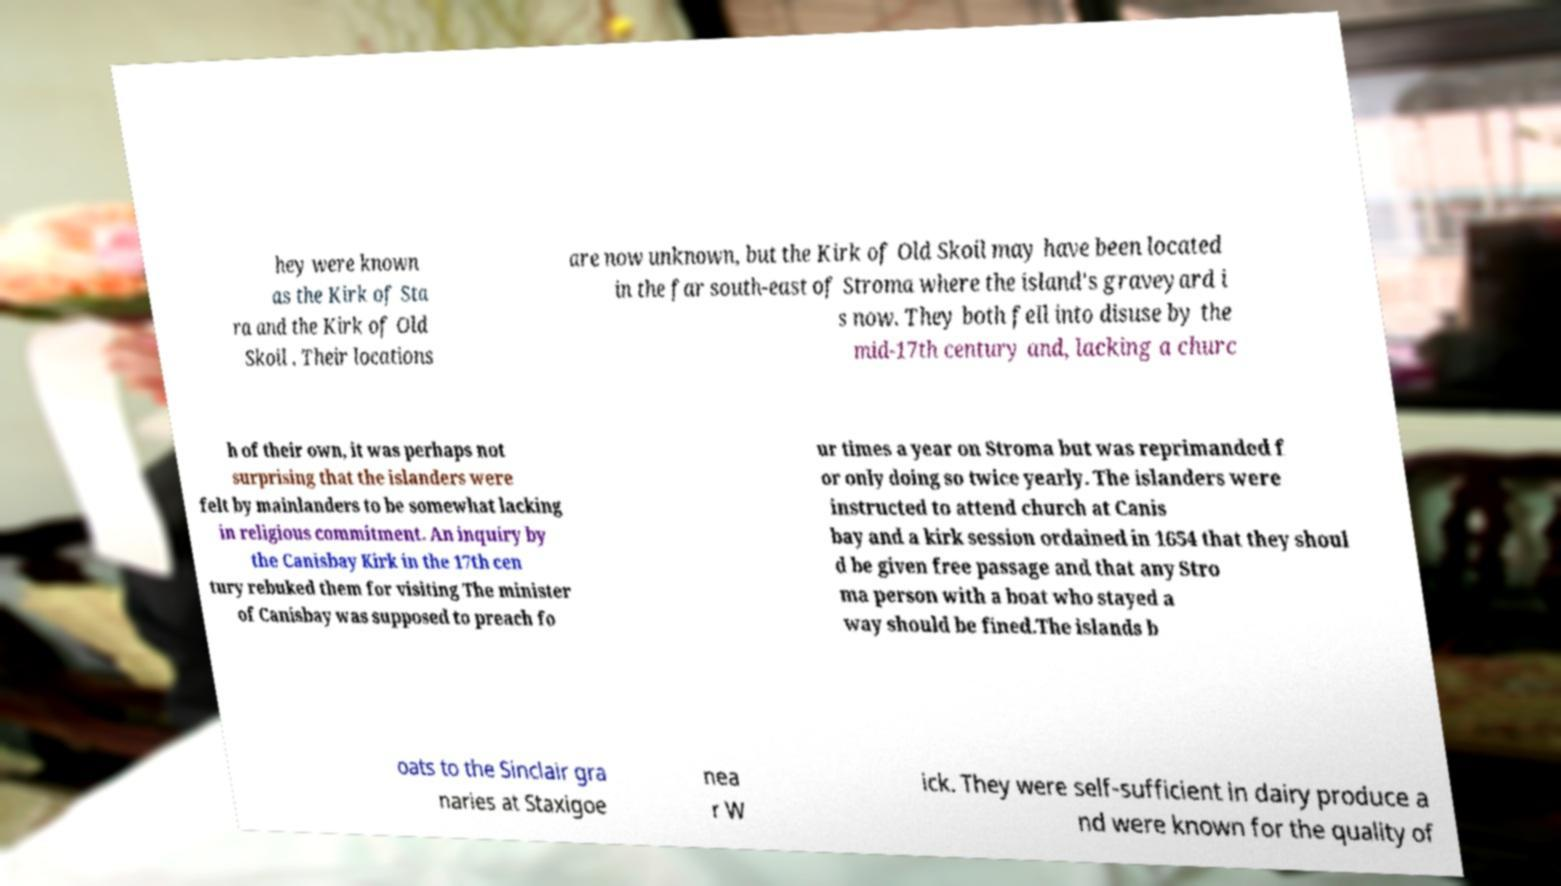Please identify and transcribe the text found in this image. hey were known as the Kirk of Sta ra and the Kirk of Old Skoil . Their locations are now unknown, but the Kirk of Old Skoil may have been located in the far south-east of Stroma where the island's graveyard i s now. They both fell into disuse by the mid-17th century and, lacking a churc h of their own, it was perhaps not surprising that the islanders were felt by mainlanders to be somewhat lacking in religious commitment. An inquiry by the Canisbay Kirk in the 17th cen tury rebuked them for visiting The minister of Canisbay was supposed to preach fo ur times a year on Stroma but was reprimanded f or only doing so twice yearly. The islanders were instructed to attend church at Canis bay and a kirk session ordained in 1654 that they shoul d be given free passage and that any Stro ma person with a boat who stayed a way should be fined.The islands b oats to the Sinclair gra naries at Staxigoe nea r W ick. They were self-sufficient in dairy produce a nd were known for the quality of 